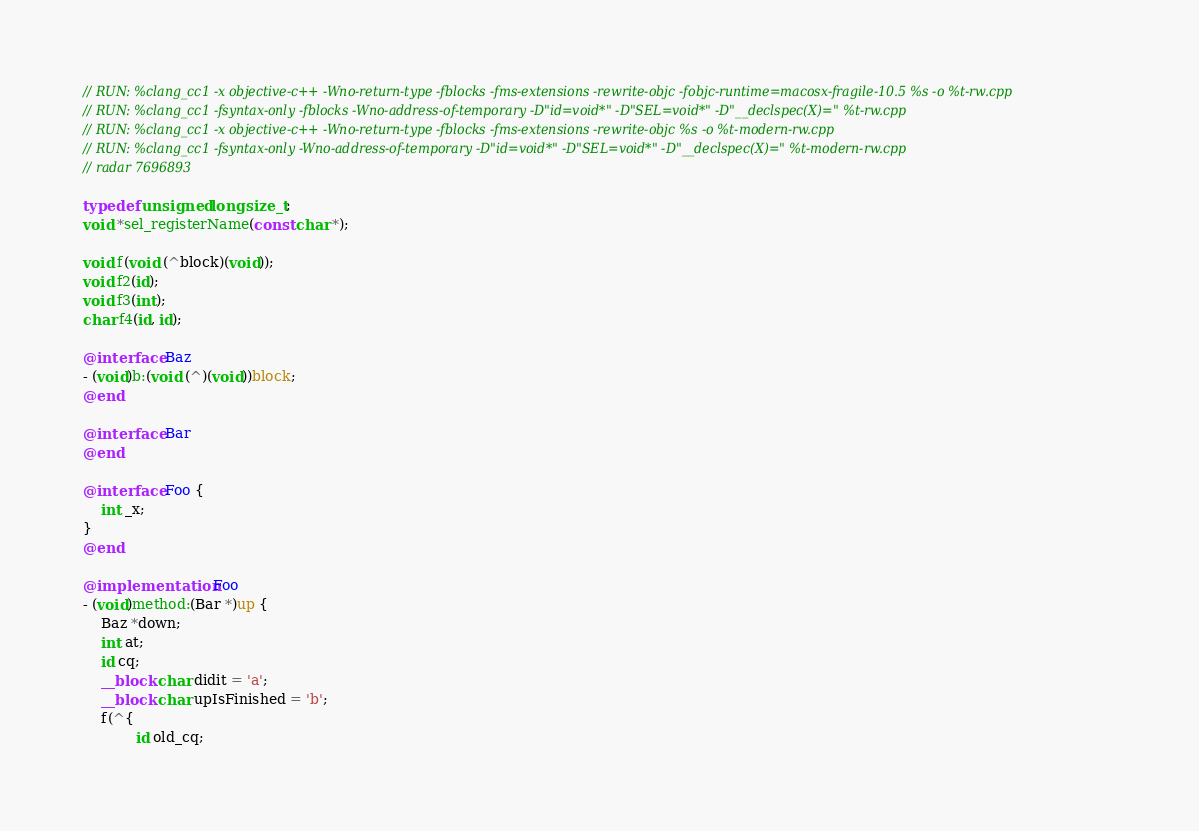<code> <loc_0><loc_0><loc_500><loc_500><_ObjectiveC_>// RUN: %clang_cc1 -x objective-c++ -Wno-return-type -fblocks -fms-extensions -rewrite-objc -fobjc-runtime=macosx-fragile-10.5 %s -o %t-rw.cpp
// RUN: %clang_cc1 -fsyntax-only -fblocks -Wno-address-of-temporary -D"id=void*" -D"SEL=void*" -D"__declspec(X)=" %t-rw.cpp
// RUN: %clang_cc1 -x objective-c++ -Wno-return-type -fblocks -fms-extensions -rewrite-objc %s -o %t-modern-rw.cpp
// RUN: %clang_cc1 -fsyntax-only -Wno-address-of-temporary -D"id=void*" -D"SEL=void*" -D"__declspec(X)=" %t-modern-rw.cpp
// radar 7696893

typedef unsigned long size_t;
void *sel_registerName(const char *);

void f(void (^block)(void));
void f2(id);
void f3(int);
char f4(id, id);

@interface Baz
- (void)b:(void (^)(void))block;
@end

@interface Bar
@end

@interface Foo {
	int _x;
}
@end

@implementation Foo
- (void)method:(Bar *)up {
    Baz *down;
	int at;
    id cq;
    __block char didit = 'a';
    __block char upIsFinished = 'b';
    f(^{
            id old_cq;</code> 